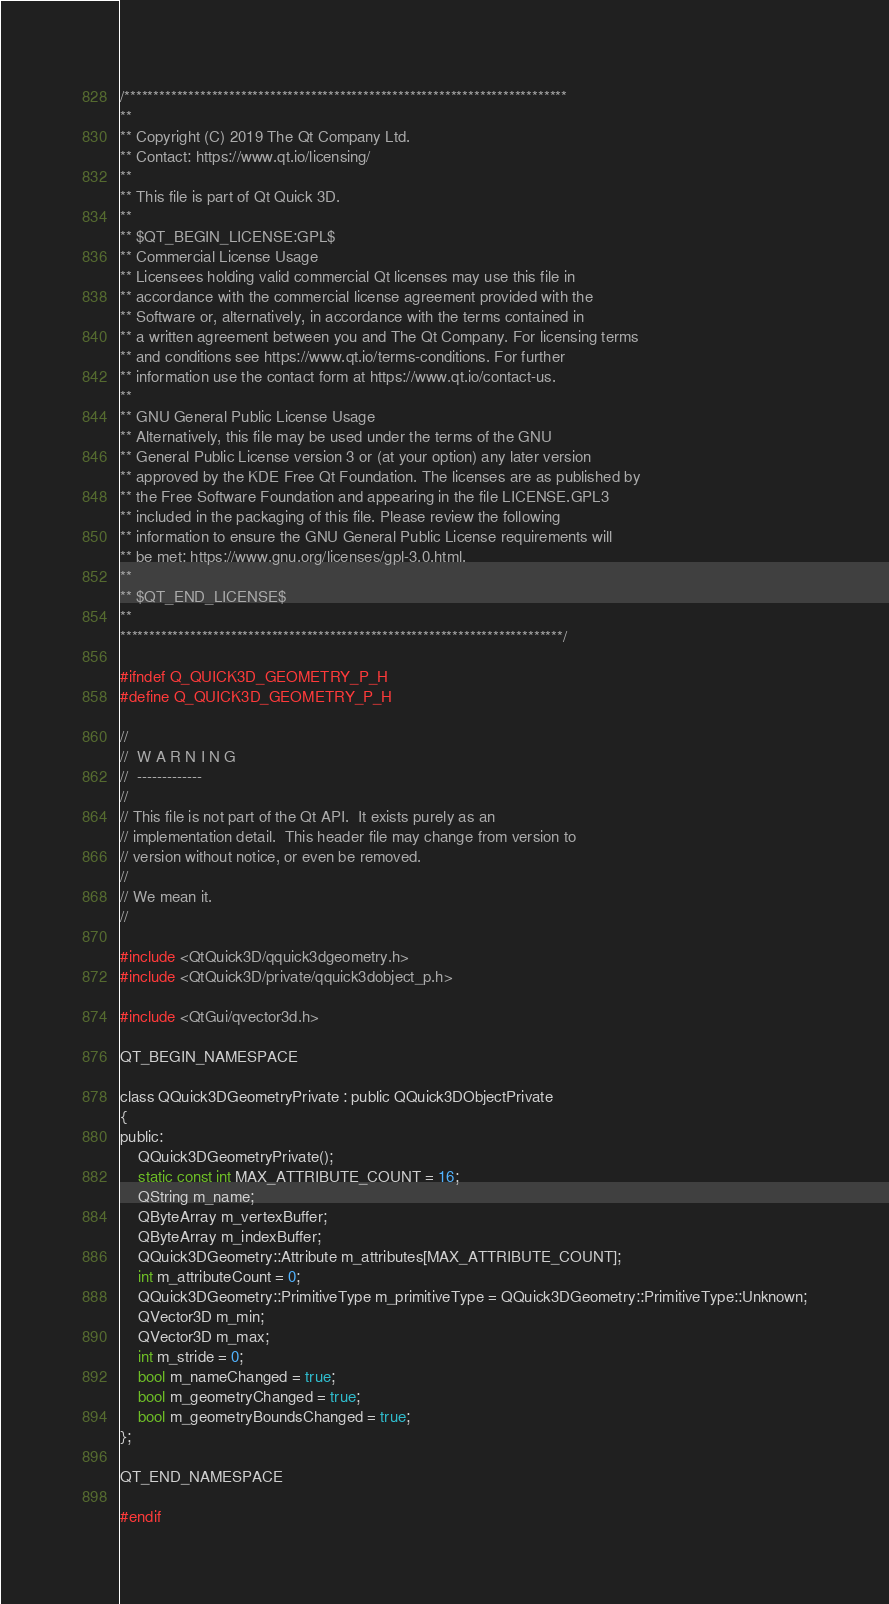Convert code to text. <code><loc_0><loc_0><loc_500><loc_500><_C_>/****************************************************************************
**
** Copyright (C) 2019 The Qt Company Ltd.
** Contact: https://www.qt.io/licensing/
**
** This file is part of Qt Quick 3D.
**
** $QT_BEGIN_LICENSE:GPL$
** Commercial License Usage
** Licensees holding valid commercial Qt licenses may use this file in
** accordance with the commercial license agreement provided with the
** Software or, alternatively, in accordance with the terms contained in
** a written agreement between you and The Qt Company. For licensing terms
** and conditions see https://www.qt.io/terms-conditions. For further
** information use the contact form at https://www.qt.io/contact-us.
**
** GNU General Public License Usage
** Alternatively, this file may be used under the terms of the GNU
** General Public License version 3 or (at your option) any later version
** approved by the KDE Free Qt Foundation. The licenses are as published by
** the Free Software Foundation and appearing in the file LICENSE.GPL3
** included in the packaging of this file. Please review the following
** information to ensure the GNU General Public License requirements will
** be met: https://www.gnu.org/licenses/gpl-3.0.html.
**
** $QT_END_LICENSE$
**
****************************************************************************/

#ifndef Q_QUICK3D_GEOMETRY_P_H
#define Q_QUICK3D_GEOMETRY_P_H

//
//  W A R N I N G
//  -------------
//
// This file is not part of the Qt API.  It exists purely as an
// implementation detail.  This header file may change from version to
// version without notice, or even be removed.
//
// We mean it.
//

#include <QtQuick3D/qquick3dgeometry.h>
#include <QtQuick3D/private/qquick3dobject_p.h>

#include <QtGui/qvector3d.h>

QT_BEGIN_NAMESPACE

class QQuick3DGeometryPrivate : public QQuick3DObjectPrivate
{
public:
    QQuick3DGeometryPrivate();
    static const int MAX_ATTRIBUTE_COUNT = 16;
    QString m_name;
    QByteArray m_vertexBuffer;
    QByteArray m_indexBuffer;
    QQuick3DGeometry::Attribute m_attributes[MAX_ATTRIBUTE_COUNT];
    int m_attributeCount = 0;
    QQuick3DGeometry::PrimitiveType m_primitiveType = QQuick3DGeometry::PrimitiveType::Unknown;
    QVector3D m_min;
    QVector3D m_max;
    int m_stride = 0;
    bool m_nameChanged = true;
    bool m_geometryChanged = true;
    bool m_geometryBoundsChanged = true;
};

QT_END_NAMESPACE

#endif
</code> 